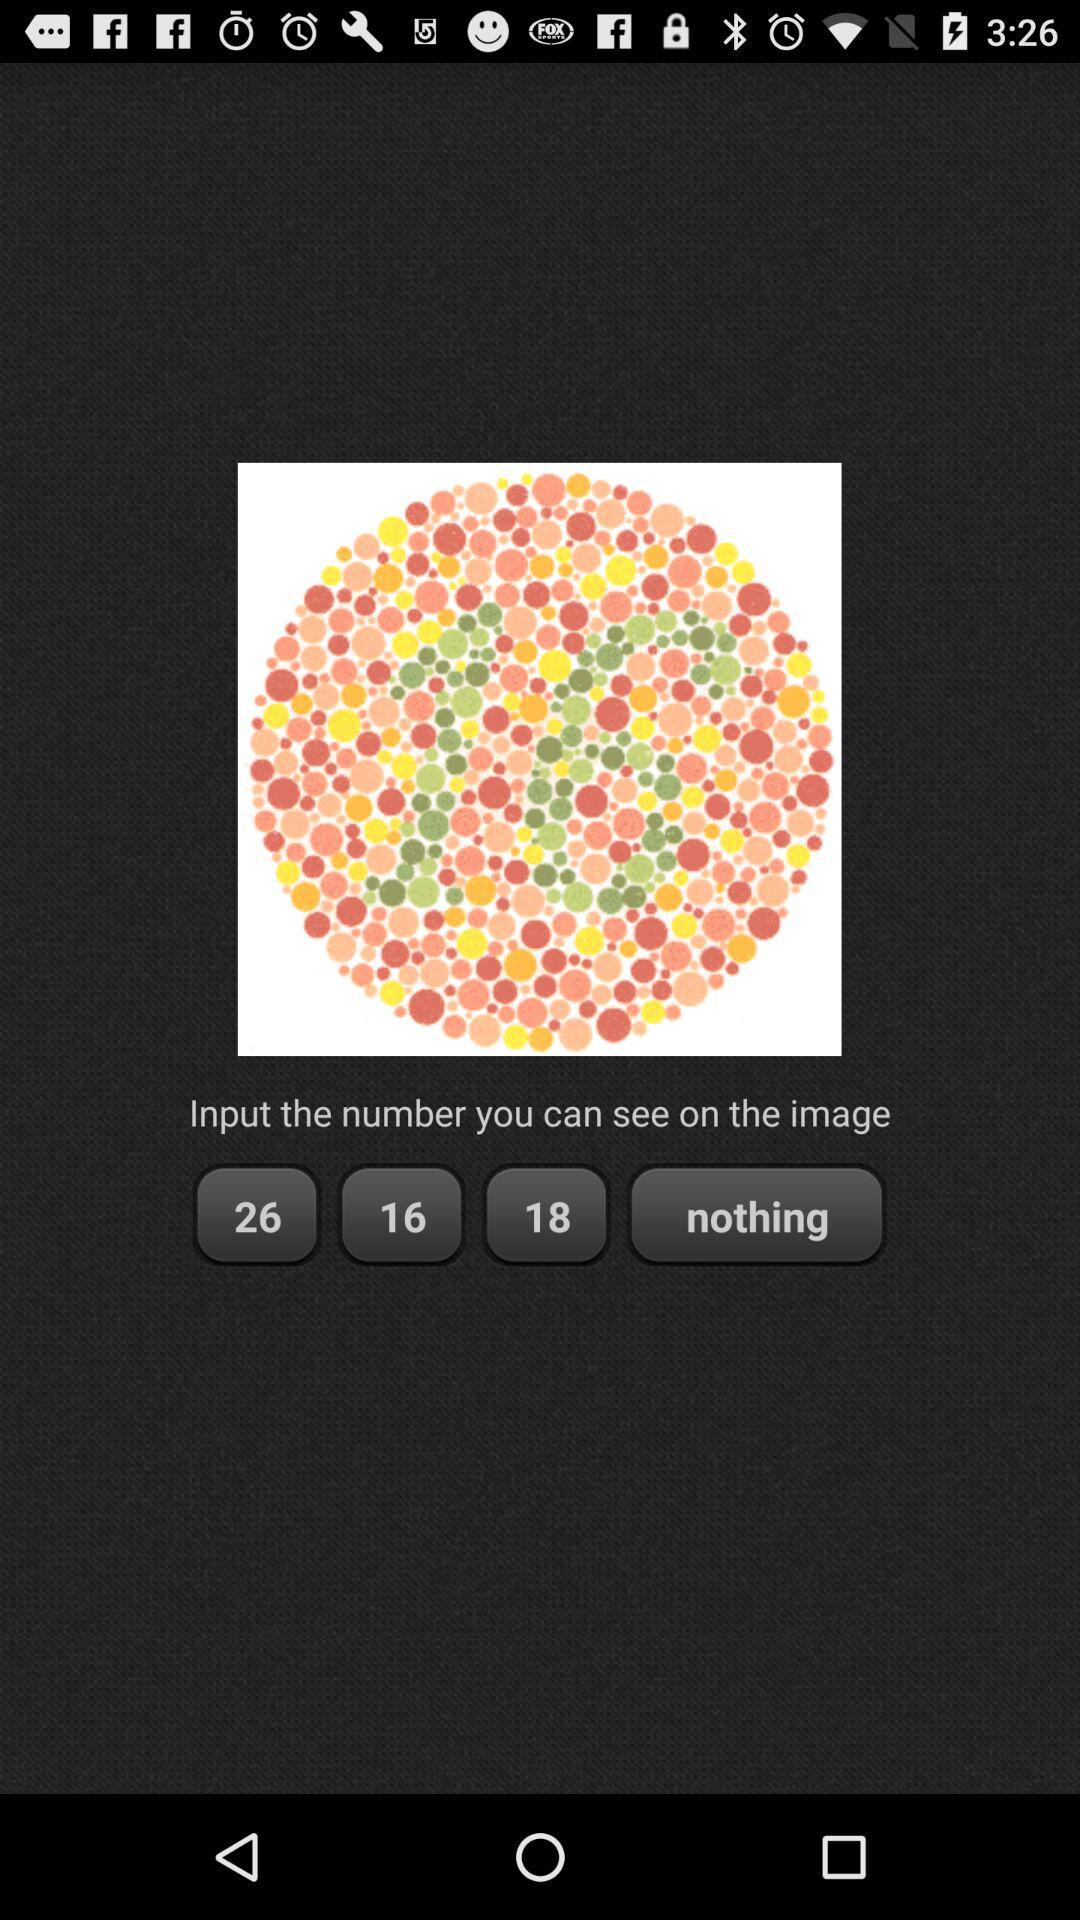What is the name of the application?
When the provided information is insufficient, respond with <no answer>. <no answer> 